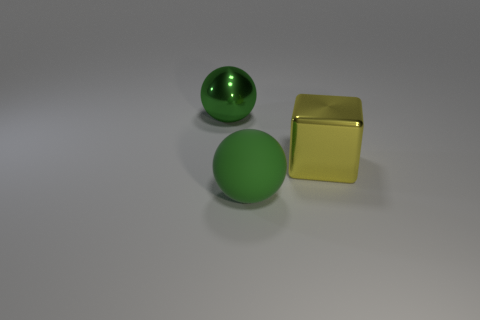How many other things are there of the same color as the matte ball?
Your response must be concise. 1. Do the metallic sphere and the rubber sphere have the same color?
Keep it short and to the point. Yes. Does the metal thing left of the yellow metal object have the same color as the big rubber sphere?
Offer a very short reply. Yes. How many other large objects have the same color as the rubber thing?
Your answer should be very brief. 1. What material is the green sphere to the left of the large ball in front of the object behind the yellow cube?
Make the answer very short. Metal. Are there any other things that have the same shape as the large yellow object?
Keep it short and to the point. No. There is a large shiny thing that is the same shape as the green matte thing; what is its color?
Keep it short and to the point. Green. There is a shiny sphere to the left of the large yellow shiny cube; is it the same color as the big sphere in front of the yellow block?
Your response must be concise. Yes. Are there more big metallic things that are behind the big cube than small yellow cubes?
Make the answer very short. Yes. How many large objects are on the left side of the cube and behind the matte object?
Ensure brevity in your answer.  1. 